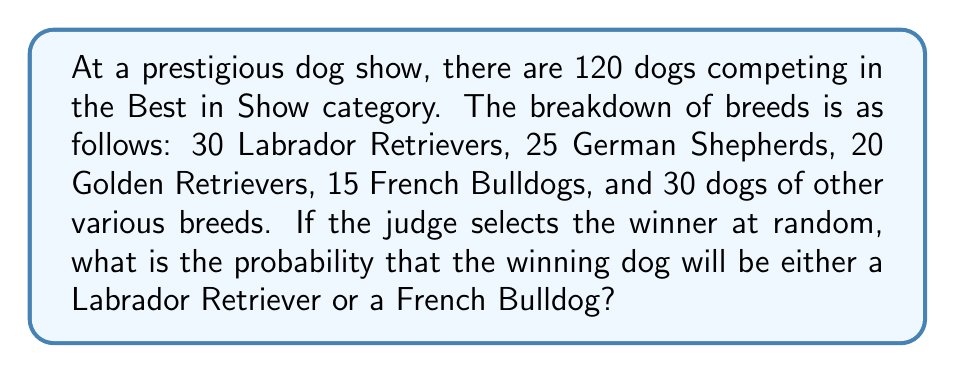Solve this math problem. To solve this problem, we need to follow these steps:

1. Identify the total number of dogs in the show:
   $$ \text{Total dogs} = 120 $$

2. Identify the number of favorable outcomes:
   - Labrador Retrievers: 30
   - French Bulldogs: 15
   $$ \text{Favorable outcomes} = 30 + 15 = 45 $$

3. Calculate the probability using the formula:
   $$ P(\text{event}) = \frac{\text{number of favorable outcomes}}{\text{total number of possible outcomes}} $$

4. Substitute the values:
   $$ P(\text{Labrador Retriever or French Bulldog}) = \frac{45}{120} $$

5. Simplify the fraction:
   $$ P(\text{Labrador Retriever or French Bulldog}) = \frac{3}{8} = 0.375 $$

Therefore, the probability that the winning dog will be either a Labrador Retriever or a French Bulldog is $\frac{3}{8}$ or 0.375 or 37.5%.
Answer: $\frac{3}{8}$ or 0.375 or 37.5% 